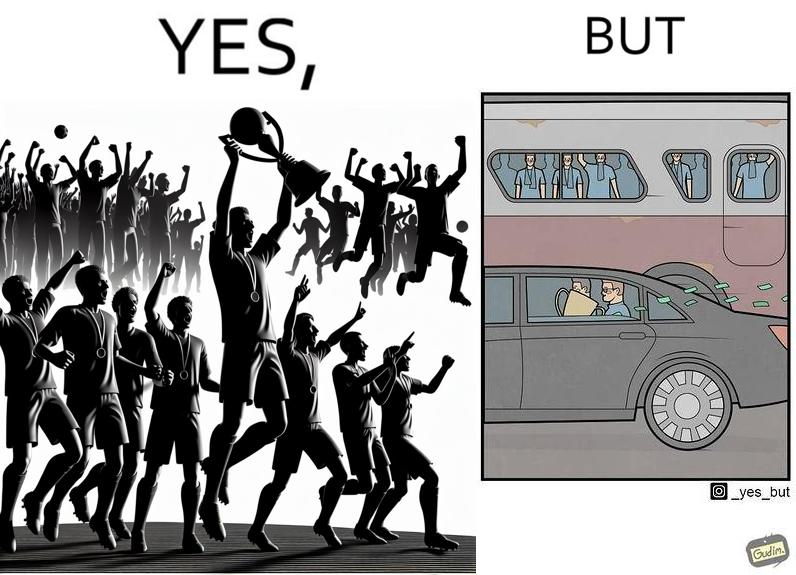Provide a description of this image. The image is ironical, as a team and its are all celebrating on the ground after winning the match, but after the match, the fans are standing in the bus uncomfortably, while the players are travelling inside a carring the cup as well as the prize money, which the fans did not get a dime of. 